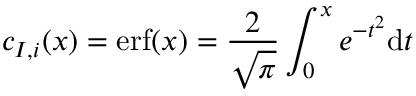Convert formula to latex. <formula><loc_0><loc_0><loc_500><loc_500>c _ { I , i } ( x ) = e r f ( x ) = \frac { 2 } { \sqrt { \pi } } \int _ { 0 } ^ { x } e ^ { - t ^ { 2 } } d t</formula> 